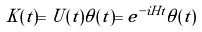Convert formula to latex. <formula><loc_0><loc_0><loc_500><loc_500>K ( t ) = U ( t ) \theta ( t ) = e ^ { - i H t } \theta ( t )</formula> 